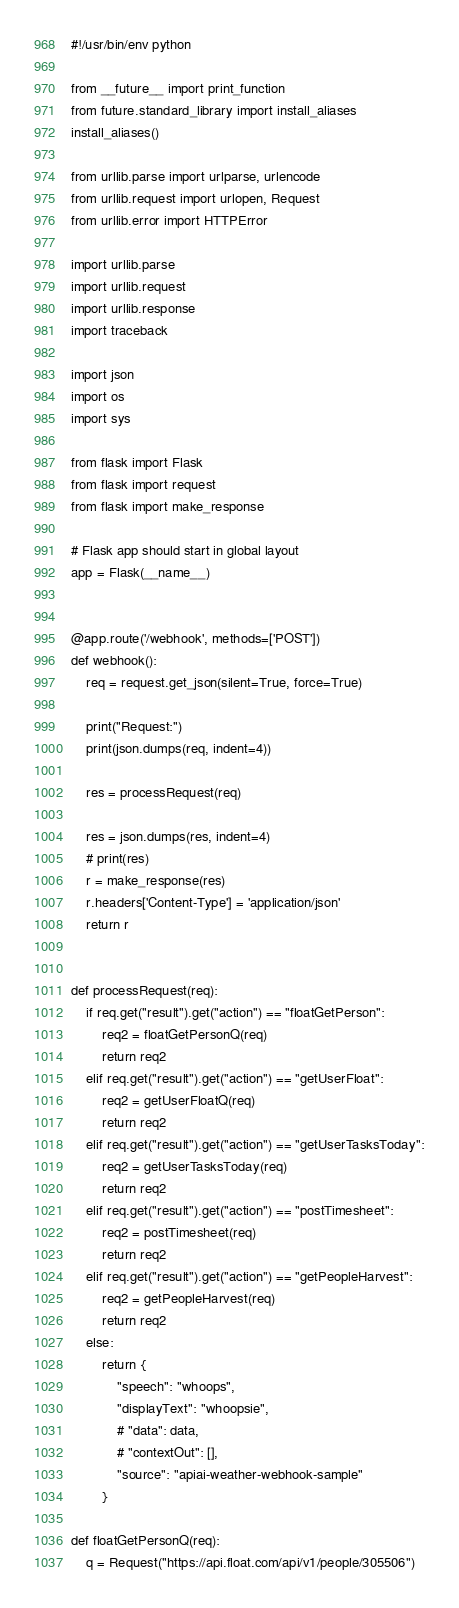<code> <loc_0><loc_0><loc_500><loc_500><_Python_>#!/usr/bin/env python

from __future__ import print_function
from future.standard_library import install_aliases
install_aliases()

from urllib.parse import urlparse, urlencode
from urllib.request import urlopen, Request
from urllib.error import HTTPError

import urllib.parse
import urllib.request
import urllib.response
import traceback

import json
import os
import sys

from flask import Flask
from flask import request
from flask import make_response

# Flask app should start in global layout
app = Flask(__name__)


@app.route('/webhook', methods=['POST'])
def webhook():
    req = request.get_json(silent=True, force=True)

    print("Request:")
    print(json.dumps(req, indent=4))

    res = processRequest(req)

    res = json.dumps(res, indent=4)
    # print(res)
    r = make_response(res)
    r.headers['Content-Type'] = 'application/json'
    return r


def processRequest(req):
    if req.get("result").get("action") == "floatGetPerson":
        req2 = floatGetPersonQ(req)
        return req2
    elif req.get("result").get("action") == "getUserFloat":
        req2 = getUserFloatQ(req)
        return req2
    elif req.get("result").get("action") == "getUserTasksToday":
        req2 = getUserTasksToday(req)
        return req2
    elif req.get("result").get("action") == "postTimesheet":
        req2 = postTimesheet(req)
        return req2
    elif req.get("result").get("action") == "getPeopleHarvest":
        req2 = getPeopleHarvest(req)
        return req2
    else:
        return {
            "speech": "whoops",
            "displayText": "whoopsie",
            # "data": data,
            # "contextOut": [],
            "source": "apiai-weather-webhook-sample"
        }

def floatGetPersonQ(req):
    q = Request("https://api.float.com/api/v1/people/305506")</code> 